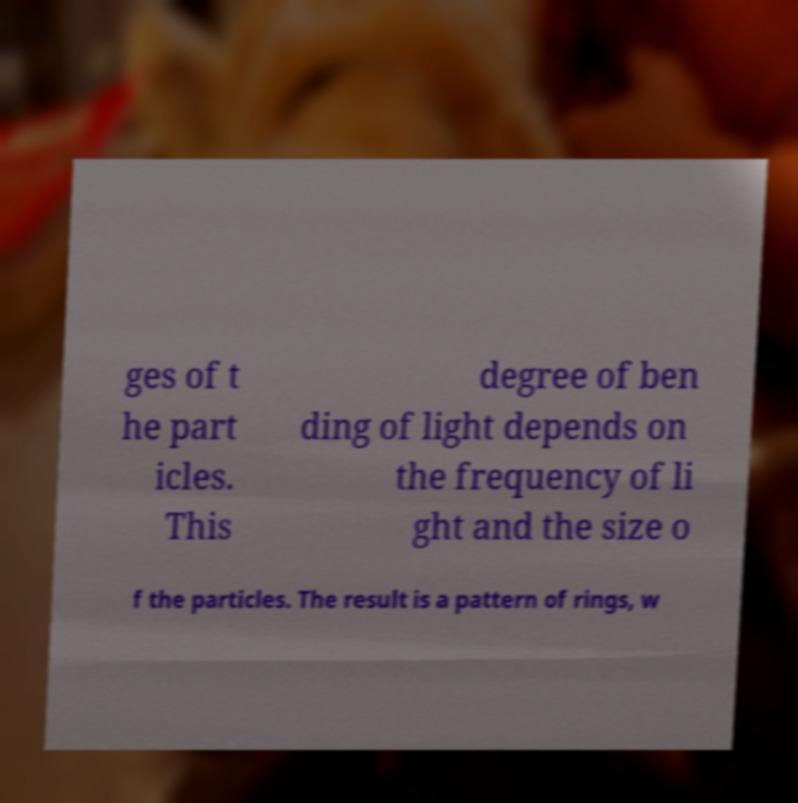Can you read and provide the text displayed in the image?This photo seems to have some interesting text. Can you extract and type it out for me? ges of t he part icles. This degree of ben ding of light depends on the frequency of li ght and the size o f the particles. The result is a pattern of rings, w 